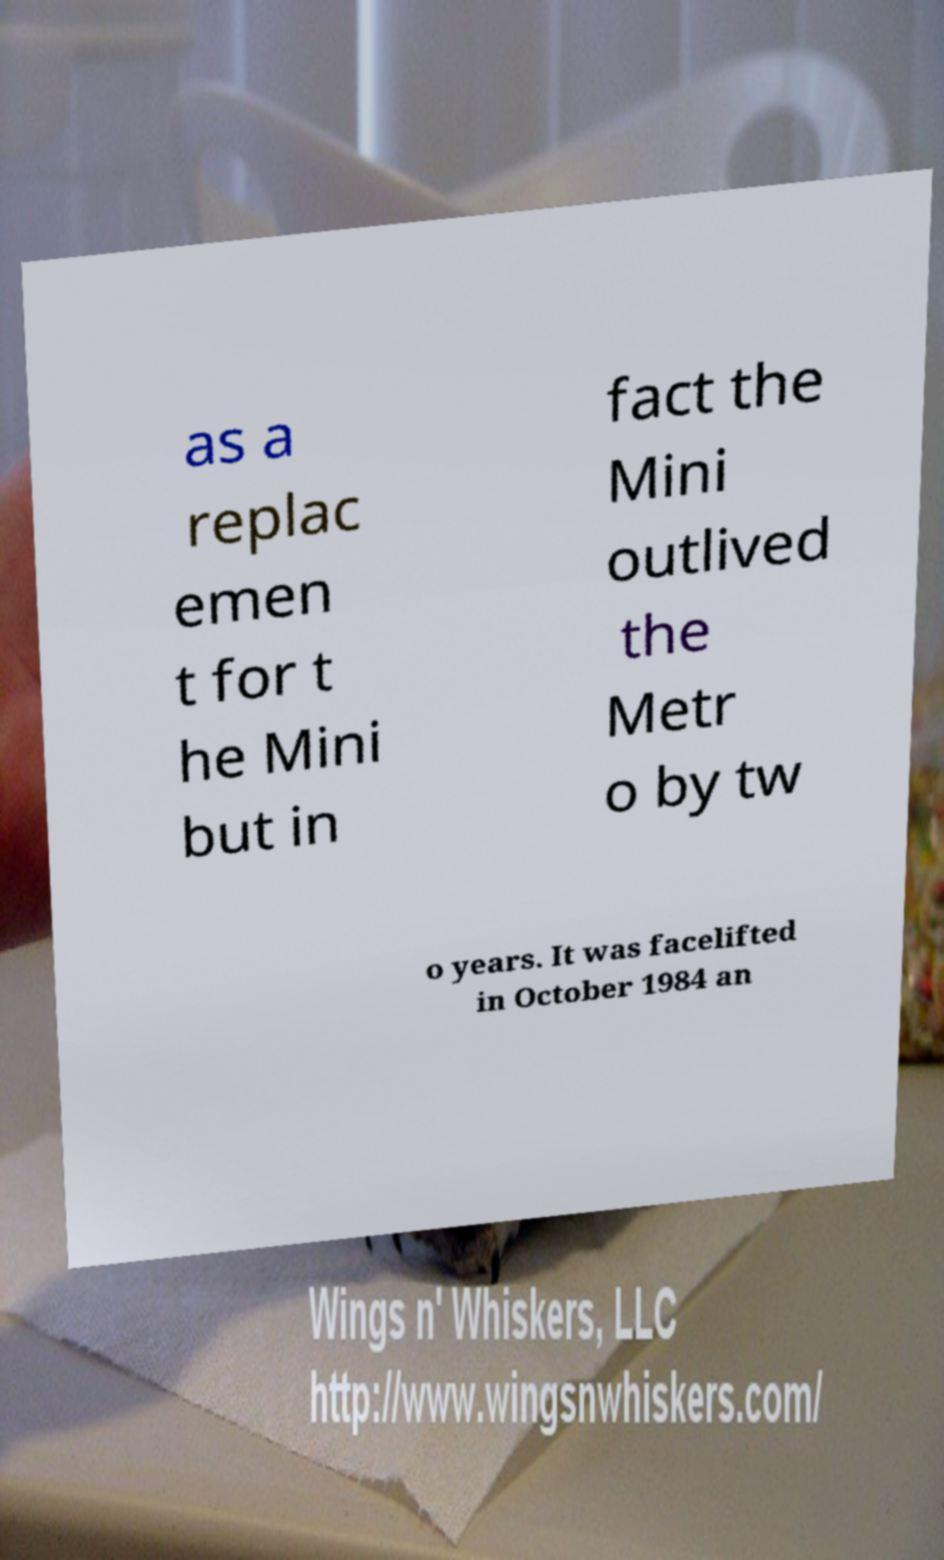Can you accurately transcribe the text from the provided image for me? as a replac emen t for t he Mini but in fact the Mini outlived the Metr o by tw o years. It was facelifted in October 1984 an 